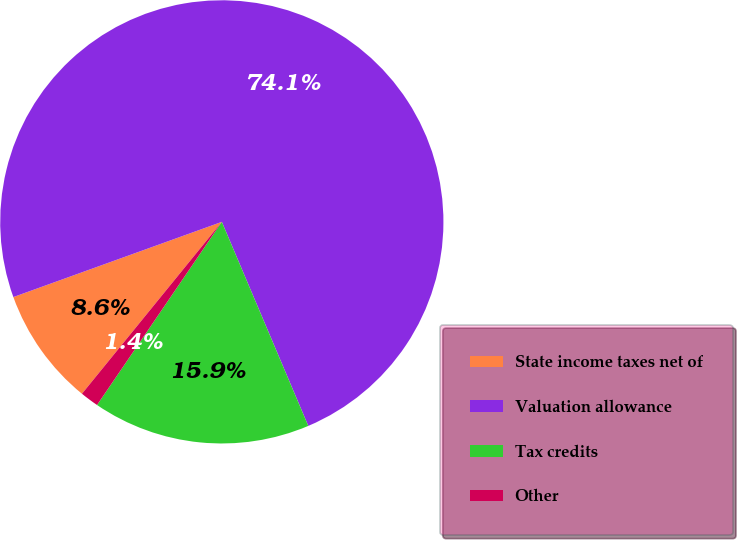Convert chart. <chart><loc_0><loc_0><loc_500><loc_500><pie_chart><fcel>State income taxes net of<fcel>Valuation allowance<fcel>Tax credits<fcel>Other<nl><fcel>8.62%<fcel>74.13%<fcel>15.9%<fcel>1.35%<nl></chart> 